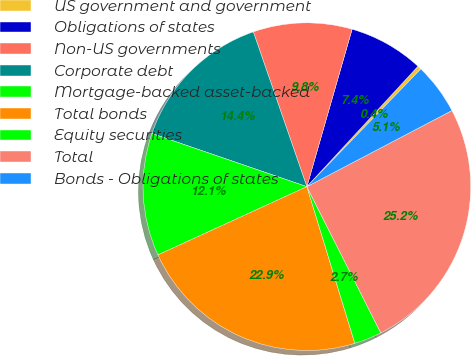Convert chart. <chart><loc_0><loc_0><loc_500><loc_500><pie_chart><fcel>US government and government<fcel>Obligations of states<fcel>Non-US governments<fcel>Corporate debt<fcel>Mortgage-backed asset-backed<fcel>Total bonds<fcel>Equity securities<fcel>Total<fcel>Bonds - Obligations of states<nl><fcel>0.38%<fcel>7.41%<fcel>9.75%<fcel>14.44%<fcel>12.1%<fcel>22.89%<fcel>2.72%<fcel>25.24%<fcel>5.07%<nl></chart> 